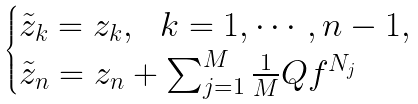Convert formula to latex. <formula><loc_0><loc_0><loc_500><loc_500>\begin{cases} \tilde { z } _ { k } = z _ { k } , \ \ k = 1 , \cdots , n - 1 , \\ \tilde { z } _ { n } = z _ { n } + \sum _ { j = 1 } ^ { M } \frac { 1 } { M } Q f ^ { N _ { j } } \end{cases}</formula> 